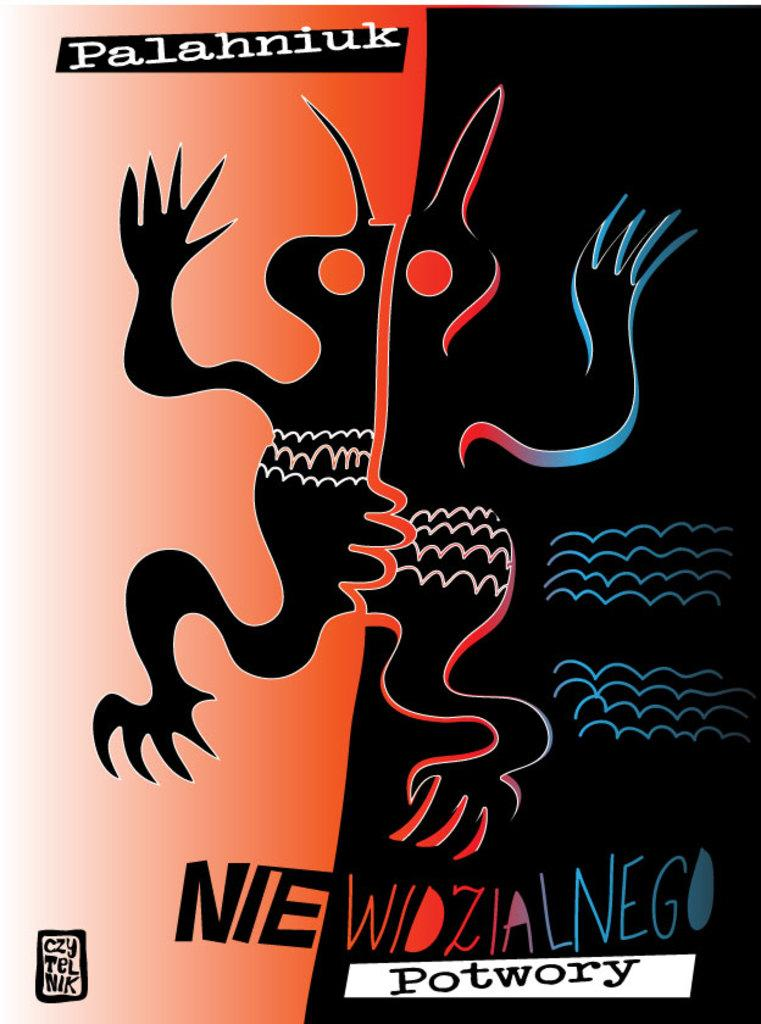What type of character is depicted in the image? There is a cartoon in the image that resembles an animal. What text can be found at the bottom of the image? There is a quotation at the bottom of the image. Where is the watermark located in the image? There is a watermark in the top left corner of the image. How many turkeys are present in the image? There are no turkeys present in the image; it features a cartoon animal that resembles an animal, but it is not a turkey. What is the primary use of the watermark in the image? The watermark in the image does not have a primary use within the image itself, as it is likely for copyright or identification purposes. 